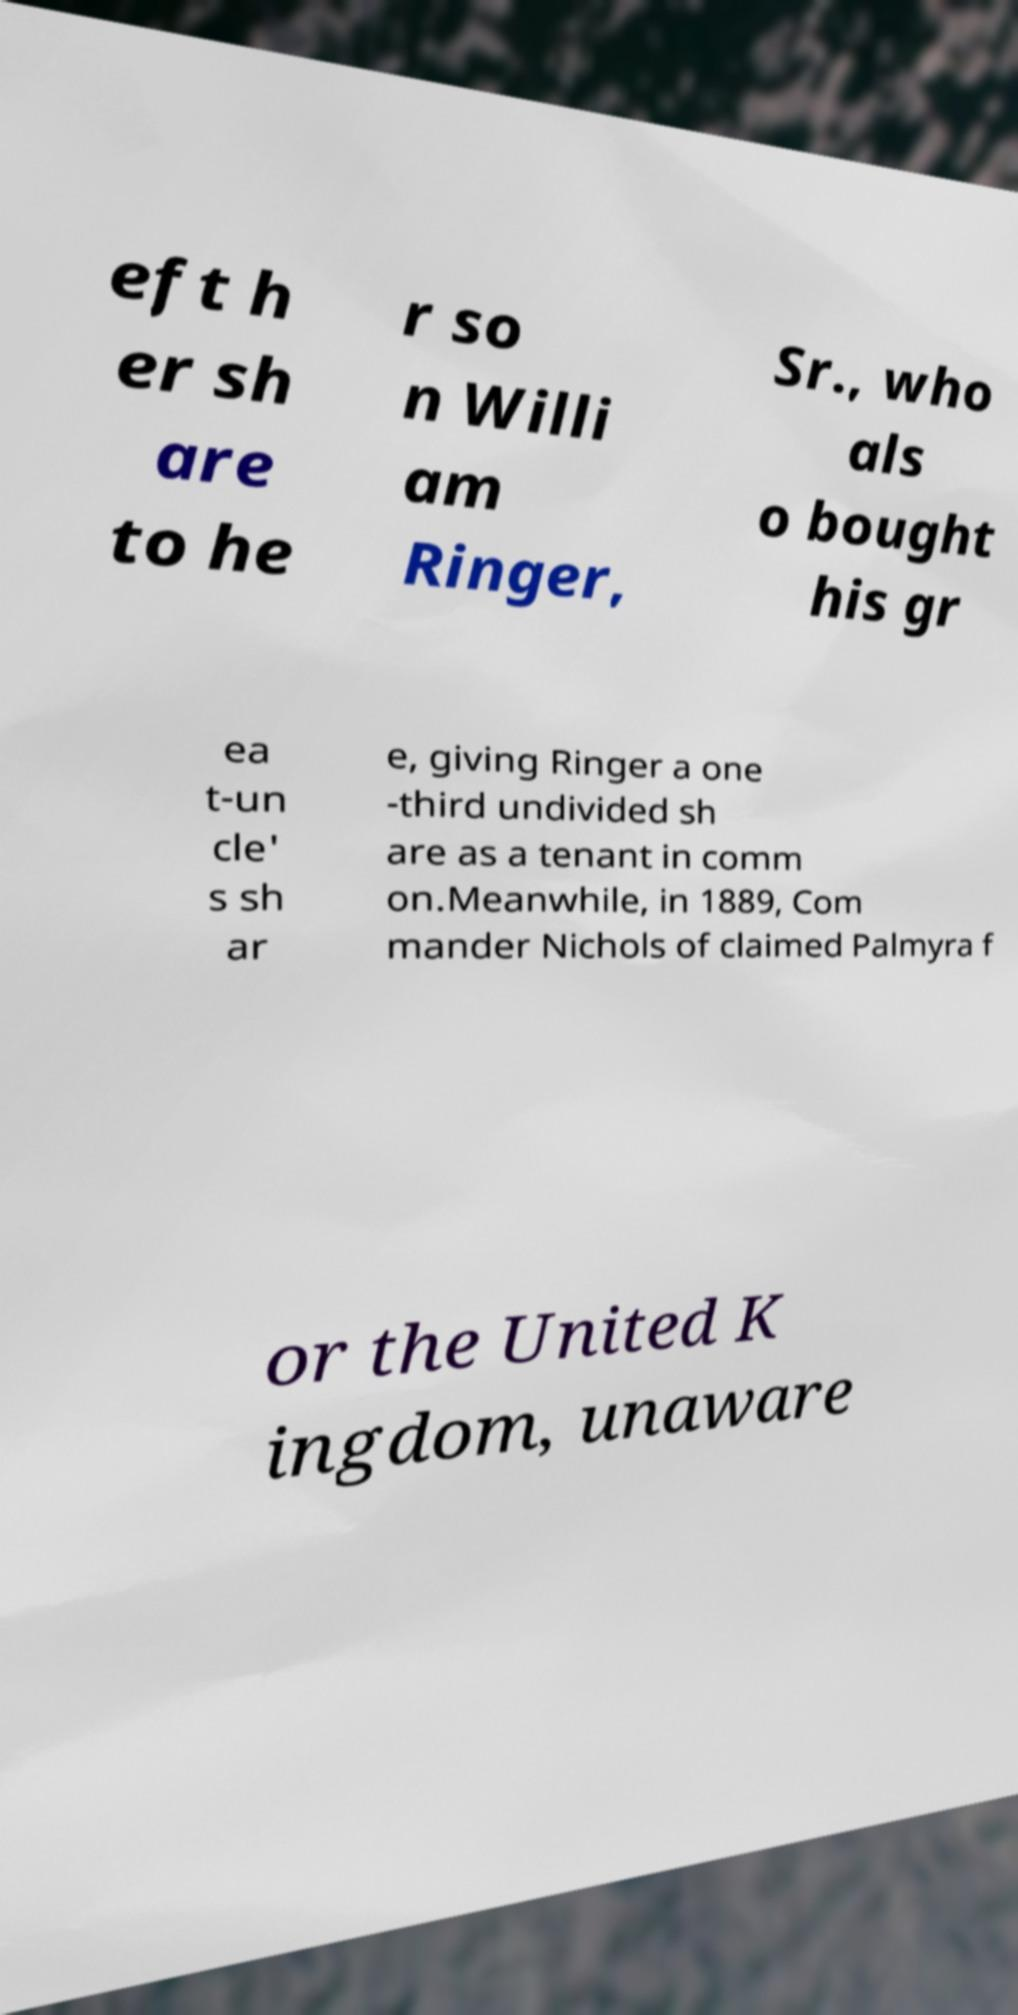Can you read and provide the text displayed in the image?This photo seems to have some interesting text. Can you extract and type it out for me? eft h er sh are to he r so n Willi am Ringer, Sr., who als o bought his gr ea t-un cle' s sh ar e, giving Ringer a one -third undivided sh are as a tenant in comm on.Meanwhile, in 1889, Com mander Nichols of claimed Palmyra f or the United K ingdom, unaware 